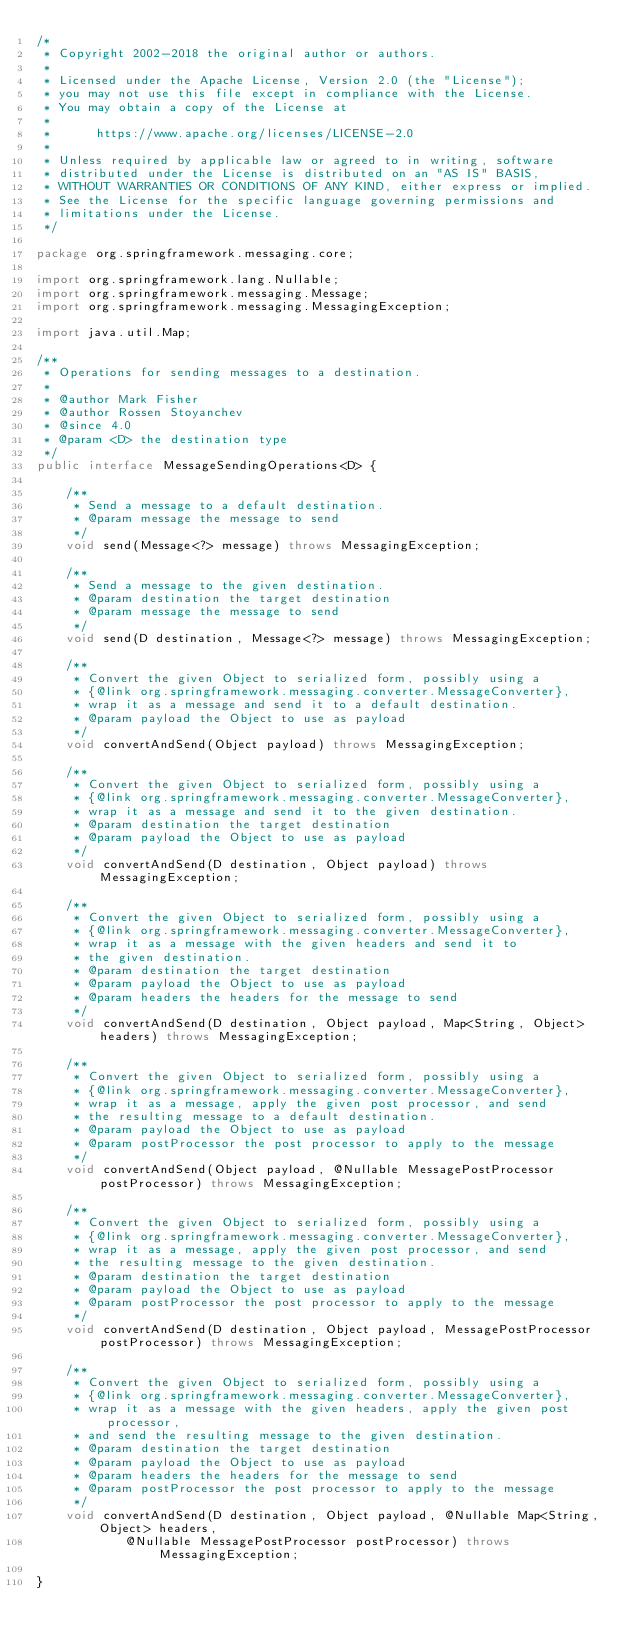Convert code to text. <code><loc_0><loc_0><loc_500><loc_500><_Java_>/*
 * Copyright 2002-2018 the original author or authors.
 *
 * Licensed under the Apache License, Version 2.0 (the "License");
 * you may not use this file except in compliance with the License.
 * You may obtain a copy of the License at
 *
 *      https://www.apache.org/licenses/LICENSE-2.0
 *
 * Unless required by applicable law or agreed to in writing, software
 * distributed under the License is distributed on an "AS IS" BASIS,
 * WITHOUT WARRANTIES OR CONDITIONS OF ANY KIND, either express or implied.
 * See the License for the specific language governing permissions and
 * limitations under the License.
 */

package org.springframework.messaging.core;

import org.springframework.lang.Nullable;
import org.springframework.messaging.Message;
import org.springframework.messaging.MessagingException;

import java.util.Map;

/**
 * Operations for sending messages to a destination.
 *
 * @author Mark Fisher
 * @author Rossen Stoyanchev
 * @since 4.0
 * @param <D> the destination type
 */
public interface MessageSendingOperations<D> {

	/**
	 * Send a message to a default destination.
	 * @param message the message to send
	 */
	void send(Message<?> message) throws MessagingException;

	/**
	 * Send a message to the given destination.
	 * @param destination the target destination
	 * @param message the message to send
	 */
	void send(D destination, Message<?> message) throws MessagingException;

	/**
	 * Convert the given Object to serialized form, possibly using a
	 * {@link org.springframework.messaging.converter.MessageConverter},
	 * wrap it as a message and send it to a default destination.
	 * @param payload the Object to use as payload
	 */
	void convertAndSend(Object payload) throws MessagingException;

	/**
	 * Convert the given Object to serialized form, possibly using a
	 * {@link org.springframework.messaging.converter.MessageConverter},
	 * wrap it as a message and send it to the given destination.
	 * @param destination the target destination
	 * @param payload the Object to use as payload
	 */
	void convertAndSend(D destination, Object payload) throws MessagingException;

	/**
	 * Convert the given Object to serialized form, possibly using a
	 * {@link org.springframework.messaging.converter.MessageConverter},
	 * wrap it as a message with the given headers and send it to
	 * the given destination.
	 * @param destination the target destination
	 * @param payload the Object to use as payload
	 * @param headers the headers for the message to send
	 */
	void convertAndSend(D destination, Object payload, Map<String, Object> headers) throws MessagingException;

	/**
	 * Convert the given Object to serialized form, possibly using a
	 * {@link org.springframework.messaging.converter.MessageConverter},
	 * wrap it as a message, apply the given post processor, and send
	 * the resulting message to a default destination.
	 * @param payload the Object to use as payload
	 * @param postProcessor the post processor to apply to the message
	 */
	void convertAndSend(Object payload, @Nullable MessagePostProcessor postProcessor) throws MessagingException;

	/**
	 * Convert the given Object to serialized form, possibly using a
	 * {@link org.springframework.messaging.converter.MessageConverter},
	 * wrap it as a message, apply the given post processor, and send
	 * the resulting message to the given destination.
	 * @param destination the target destination
	 * @param payload the Object to use as payload
	 * @param postProcessor the post processor to apply to the message
	 */
	void convertAndSend(D destination, Object payload, MessagePostProcessor postProcessor) throws MessagingException;

	/**
	 * Convert the given Object to serialized form, possibly using a
	 * {@link org.springframework.messaging.converter.MessageConverter},
	 * wrap it as a message with the given headers, apply the given post processor,
	 * and send the resulting message to the given destination.
	 * @param destination the target destination
	 * @param payload the Object to use as payload
	 * @param headers the headers for the message to send
	 * @param postProcessor the post processor to apply to the message
	 */
	void convertAndSend(D destination, Object payload, @Nullable Map<String, Object> headers,
			@Nullable MessagePostProcessor postProcessor) throws MessagingException;

}
</code> 